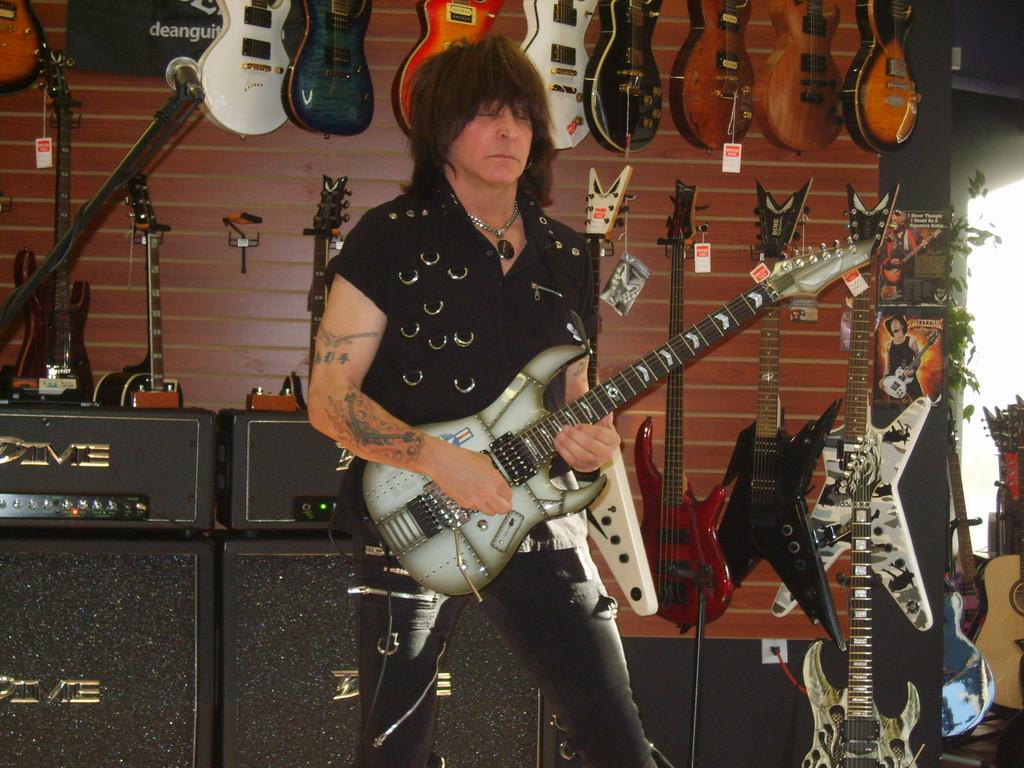What is the man in the image doing? The man is standing in the image and holding a guitar. What else can be seen in the image related to music? There are other musical instruments hanging in the background. What type of card is the man using to play the guitar in the image? There is no card present in the image, and the man is not using any card to play the guitar. 